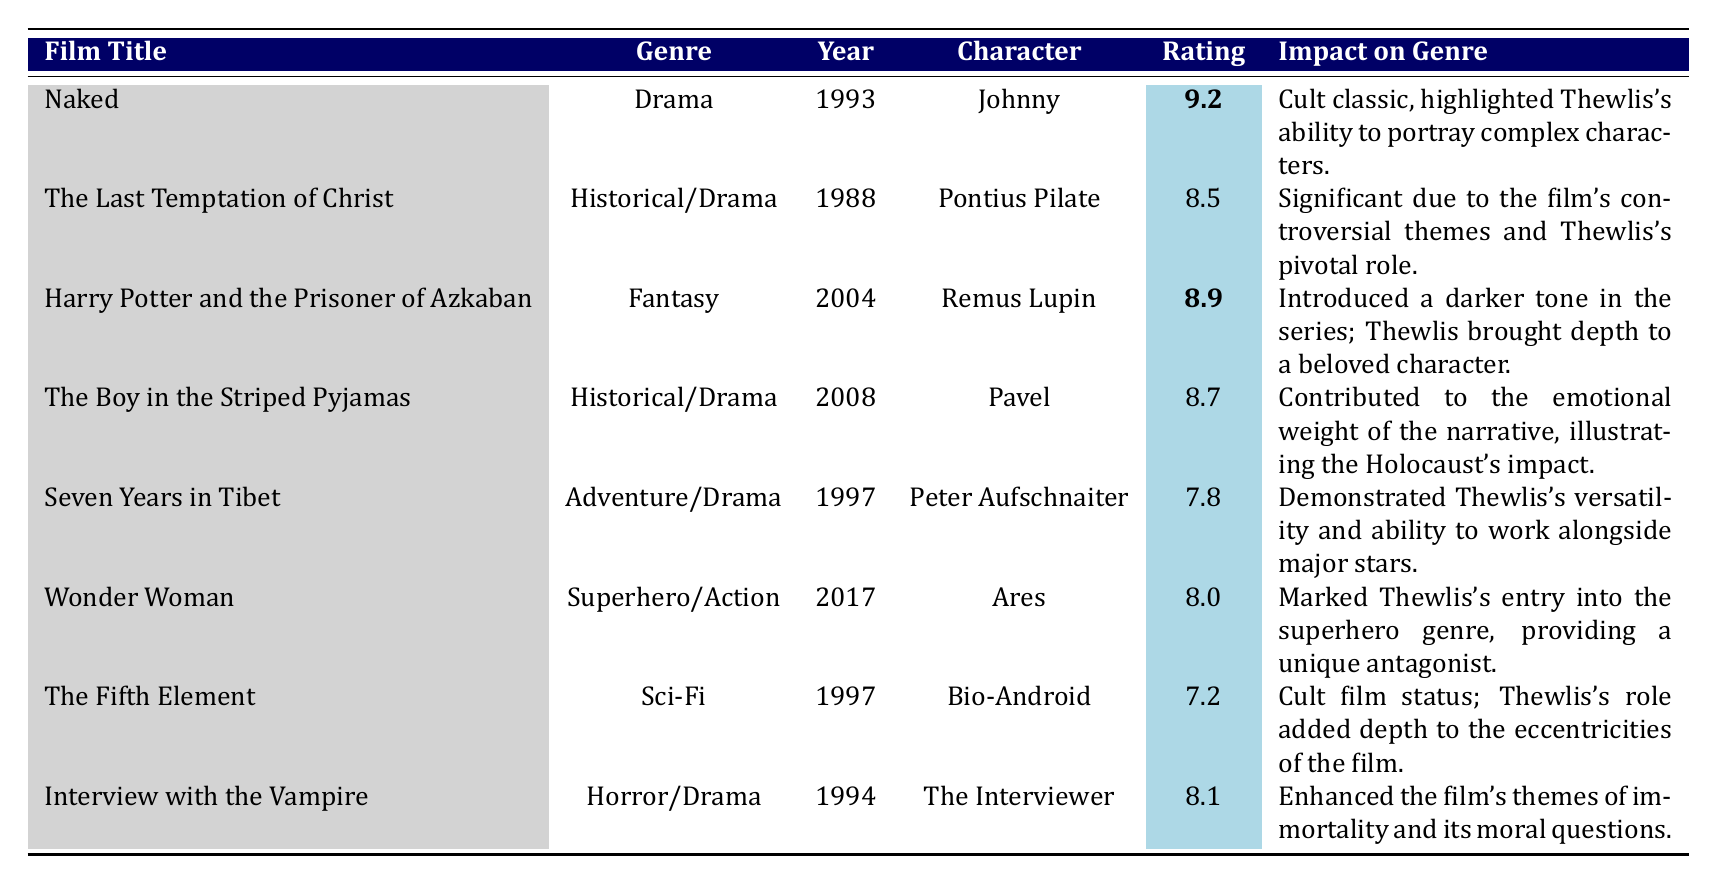What is the performance rating of the film "Naked"? The performance rating is directly provided in the table next to the film title "Naked," which shows a rating of 9.2.
Answer: 9.2 Which character did David Thewlis portray in "Harry Potter and the Prisoner of Azkaban"? The table lists the film title "Harry Potter and the Prisoner of Azkaban" along with the character name in the same row, which indicates he portrayed "Remus Lupin."
Answer: Remus Lupin What genre does the film "Wonder Woman" belong to? The genre for the film "Wonder Woman" is found in the same row, specifically categorized as "Superhero/Action."
Answer: Superhero/Action Which film had the lowest performance rating? To determine this, I compare all the performance ratings in the table and find that "The Fifth Element" has the lowest at 7.2.
Answer: The Fifth Element What was the impact of David Thewlis's performance in "The Boy in the Striped Pyjamas"? Examining the impact column, it states that Thewlis's performance contributed to the emotional weight of the narrative and illustrated the Holocaust's impact.
Answer: Contributed emotional weight and illustrated the Holocaust's impact How many films in the table are categorized as Historical/Drama? By scanning the genre column, I note "The Last Temptation of Christ" and "The Boy in the Striped Pyjamas" fit this category, giving a total of two films.
Answer: 2 What is the average performance rating of David Thewlis’s roles in Historical/Drama films? The relevant films are "The Last Temptation of Christ" (8.5) and "The Boy in the Striped Pyjamas" (8.7), so the average is (8.5 + 8.7)/2 = 8.6.
Answer: 8.6 Did David Thewlis's role in "The Fifth Element" significantly impact the genre? The impact statement for "The Fifth Element" indicates it gained cult film status, suggesting it had some significance in context but isn’t described as significant to the genre overall. Thus, the answer is no.
Answer: No In which year was the film "Seven Years in Tibet" released, and what type of character did Thewlis play? The table shows that "Seven Years in Tibet" was released in 1997, and David Thewlis portrayed the character "Peter Aufschnaiter."
Answer: 1997, Peter Aufschnaiter Which film has a higher performance rating, "Interview with the Vampire" or "Wonder Woman"? By comparing the ratings, "Interview with the Vampire" has a rating of 8.1 while "Wonder Woman" has 8.0, showing that "Interview with the Vampire" has the higher rating.
Answer: Interview with the Vampire 